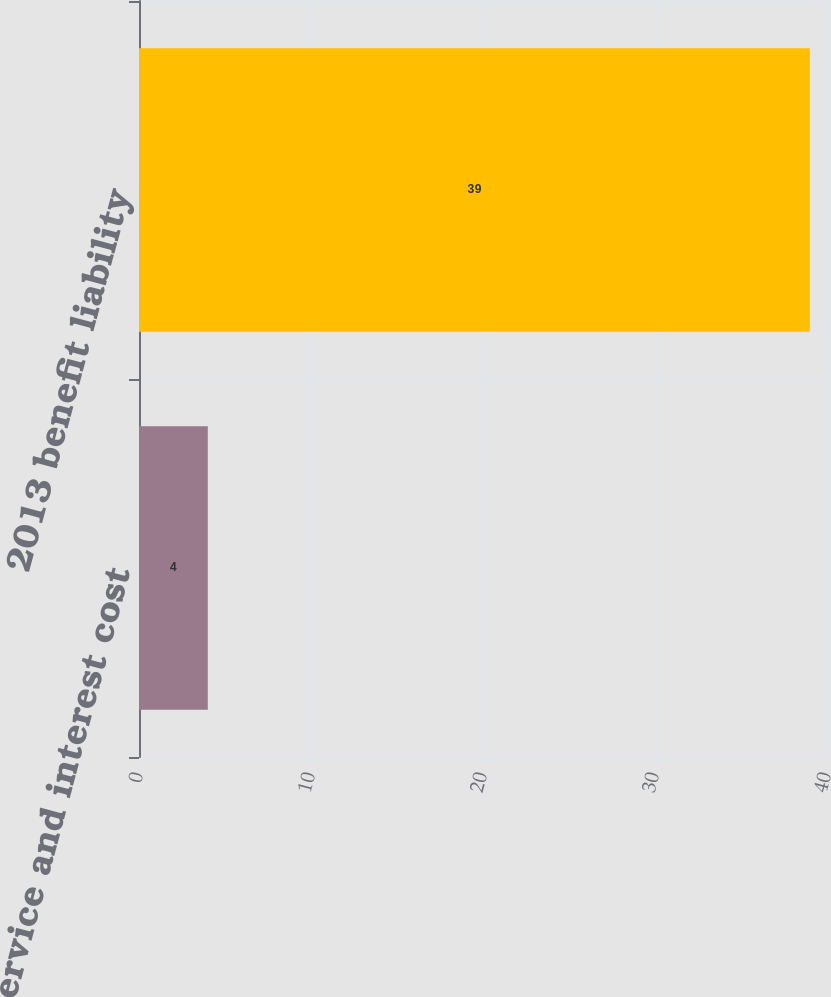<chart> <loc_0><loc_0><loc_500><loc_500><bar_chart><fcel>2013 service and interest cost<fcel>2013 benefit liability<nl><fcel>4<fcel>39<nl></chart> 